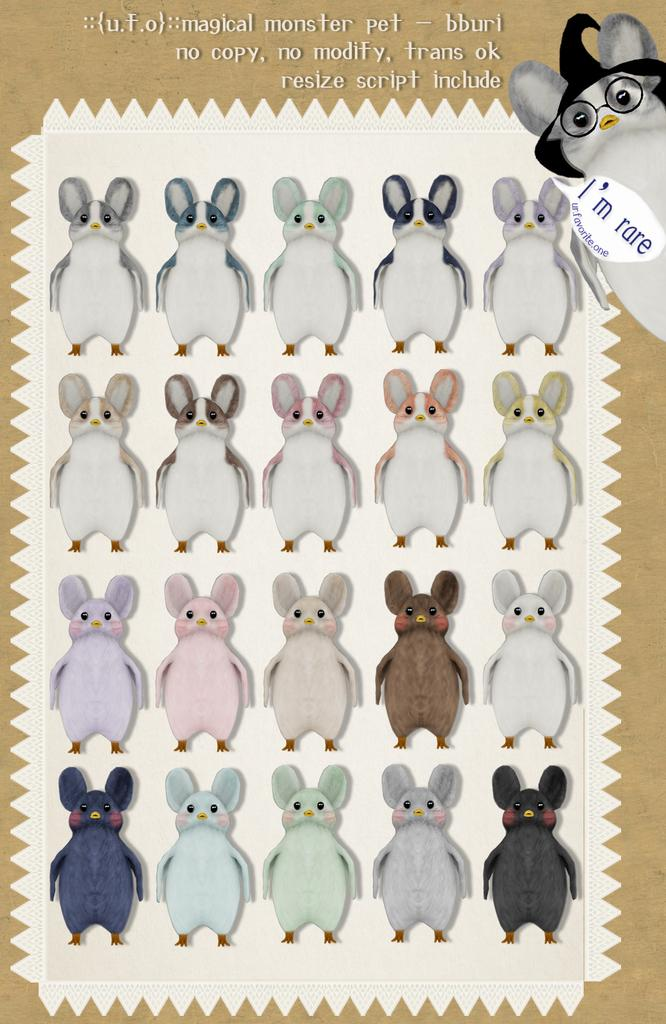What type of image is being described? The image is animated. What can be seen in the animated image? There are images of animals in the image. Is there any text present in the image? Yes, there is text written on the image. How does the stove contribute to the image? There is no stove present in the image; it features animated images of animals and text. 